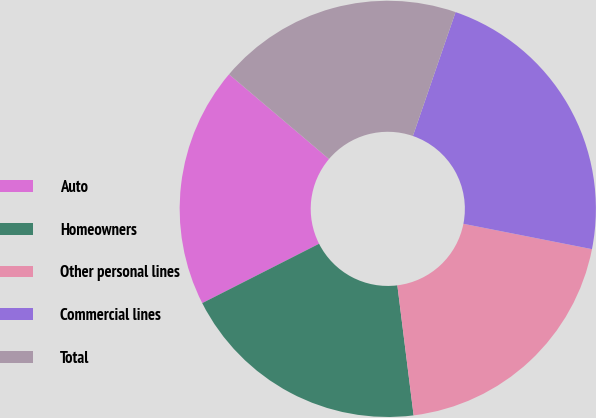Convert chart. <chart><loc_0><loc_0><loc_500><loc_500><pie_chart><fcel>Auto<fcel>Homeowners<fcel>Other personal lines<fcel>Commercial lines<fcel>Total<nl><fcel>18.67%<fcel>19.5%<fcel>19.92%<fcel>22.82%<fcel>19.09%<nl></chart> 